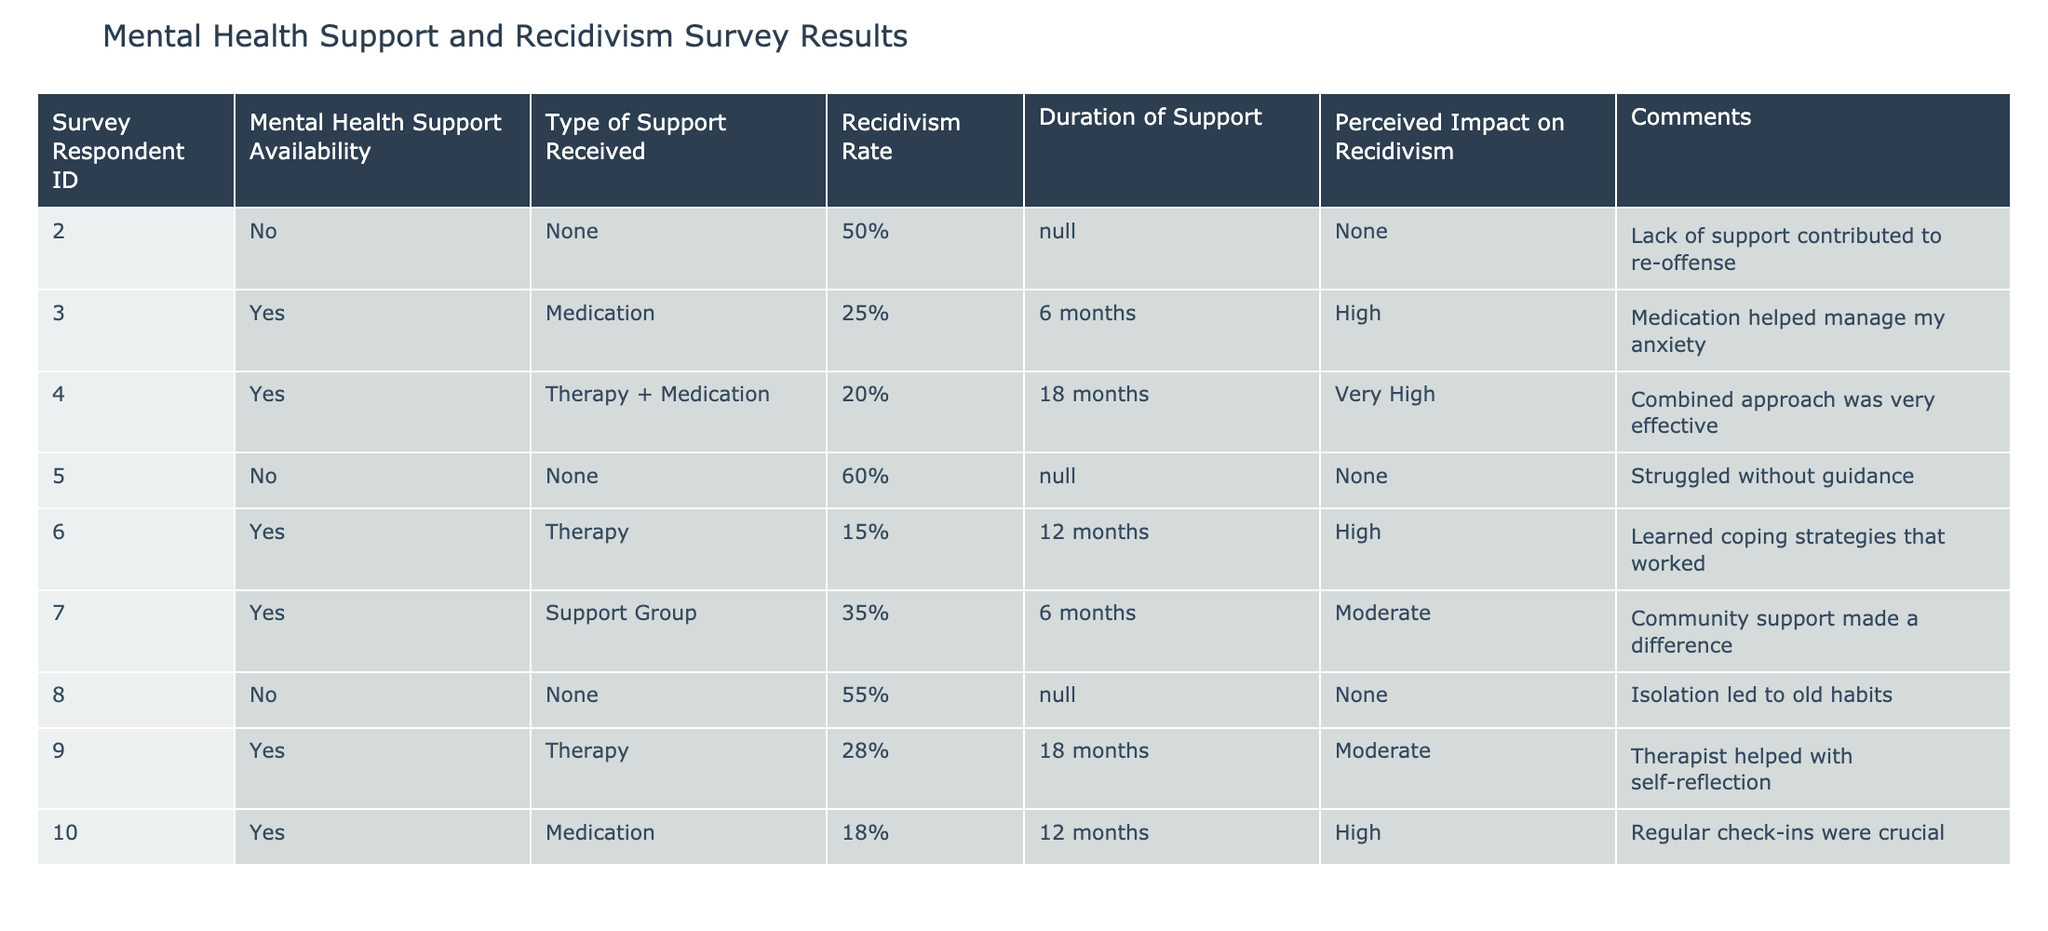What is the recidivism rate for respondents with no mental health support? There are three respondents with no mental health support whose recidivism rates are 50%, 60%, and 55%. Therefore, the recidivism rates for this group are (50 + 60 + 55) / 3 = 55%.
Answer: 55% What type of support was most commonly received by respondents? From the table, the types of support received are Medication, Therapy + Medication, Therapy, and Support Group. With the total number of respondents being 10, Therapy + Medication was received by only one respondent, while Therapy and Medication each was received by two respondents. Therefore, the most commonly received support type is Therapy, because it is reported by three respondents.
Answer: Therapy Is there any correlation between the duration of support and the recidivism rate based on the data? The table shows that shorter durations of support correspond to higher recidivism rates (e.g., 6 months with rates of 25%, 35%, and 50%), while longer durations tend to be associated with lower rates. However, the data is limited and does not strongly establish correlation. It suggests a trend but not a definitive correlation.
Answer: No definitive correlation What is the average recidivism rate among those who received therapy? The recidivism rates for respondents who received therapy are 20%, 15%, 28%, and 35%. To calculate the average, sum the rates: (20 + 15 + 28 + 35) = 98, and divide by 4, yielding an average recidivism rate of 98 / 4 = 24.5%.
Answer: 24.5% Did any individuals perceive their support as having a very high impact on recidivism? Yes, based on the data, there is one individual who perceived the impact of their support as very high, as indicated in their comments.
Answer: Yes 